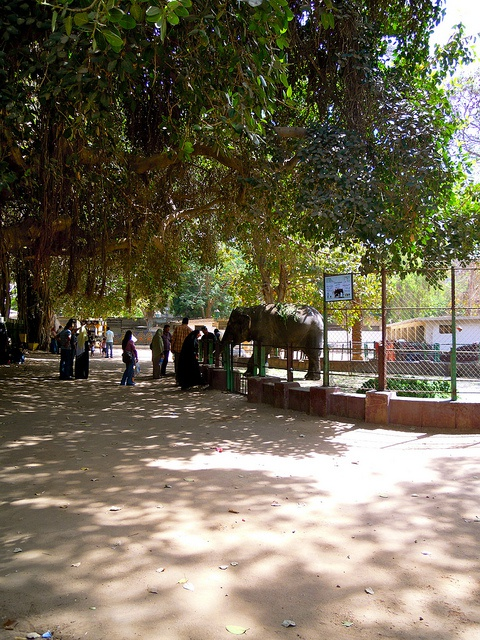Describe the objects in this image and their specific colors. I can see elephant in black, gray, darkgray, and darkgreen tones, people in black, maroon, and gray tones, people in black, gray, maroon, and navy tones, people in black, darkgreen, and gray tones, and people in black, maroon, and navy tones in this image. 